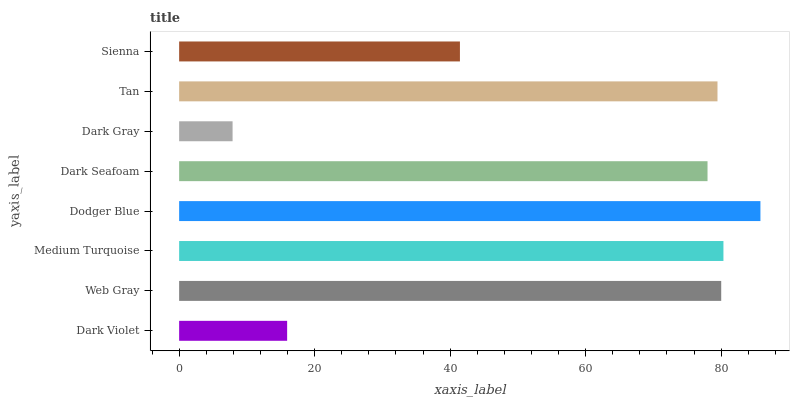Is Dark Gray the minimum?
Answer yes or no. Yes. Is Dodger Blue the maximum?
Answer yes or no. Yes. Is Web Gray the minimum?
Answer yes or no. No. Is Web Gray the maximum?
Answer yes or no. No. Is Web Gray greater than Dark Violet?
Answer yes or no. Yes. Is Dark Violet less than Web Gray?
Answer yes or no. Yes. Is Dark Violet greater than Web Gray?
Answer yes or no. No. Is Web Gray less than Dark Violet?
Answer yes or no. No. Is Tan the high median?
Answer yes or no. Yes. Is Dark Seafoam the low median?
Answer yes or no. Yes. Is Sienna the high median?
Answer yes or no. No. Is Sienna the low median?
Answer yes or no. No. 